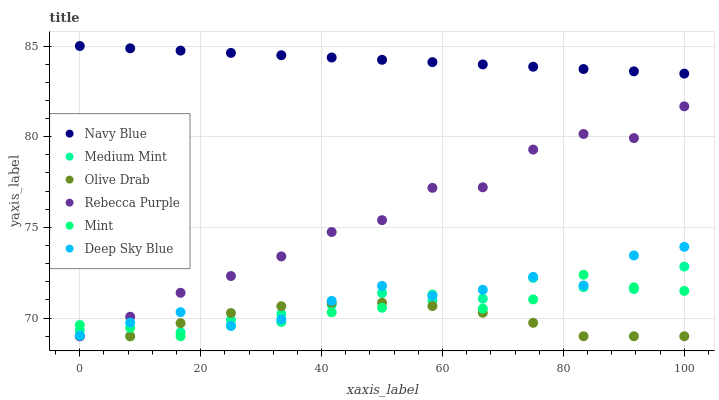Does Olive Drab have the minimum area under the curve?
Answer yes or no. Yes. Does Navy Blue have the maximum area under the curve?
Answer yes or no. Yes. Does Rebecca Purple have the minimum area under the curve?
Answer yes or no. No. Does Rebecca Purple have the maximum area under the curve?
Answer yes or no. No. Is Navy Blue the smoothest?
Answer yes or no. Yes. Is Rebecca Purple the roughest?
Answer yes or no. Yes. Is Rebecca Purple the smoothest?
Answer yes or no. No. Is Navy Blue the roughest?
Answer yes or no. No. Does Medium Mint have the lowest value?
Answer yes or no. Yes. Does Navy Blue have the lowest value?
Answer yes or no. No. Does Navy Blue have the highest value?
Answer yes or no. Yes. Does Rebecca Purple have the highest value?
Answer yes or no. No. Is Olive Drab less than Navy Blue?
Answer yes or no. Yes. Is Navy Blue greater than Mint?
Answer yes or no. Yes. Does Mint intersect Medium Mint?
Answer yes or no. Yes. Is Mint less than Medium Mint?
Answer yes or no. No. Is Mint greater than Medium Mint?
Answer yes or no. No. Does Olive Drab intersect Navy Blue?
Answer yes or no. No. 